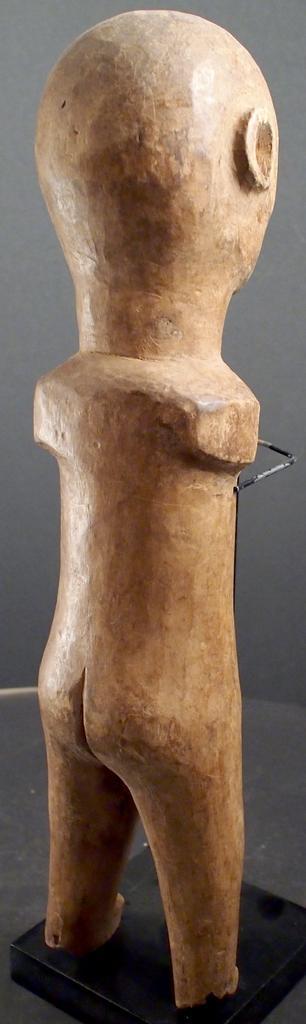How would you summarize this image in a sentence or two? In the center of the image there is a statue. In the background there is wall. 